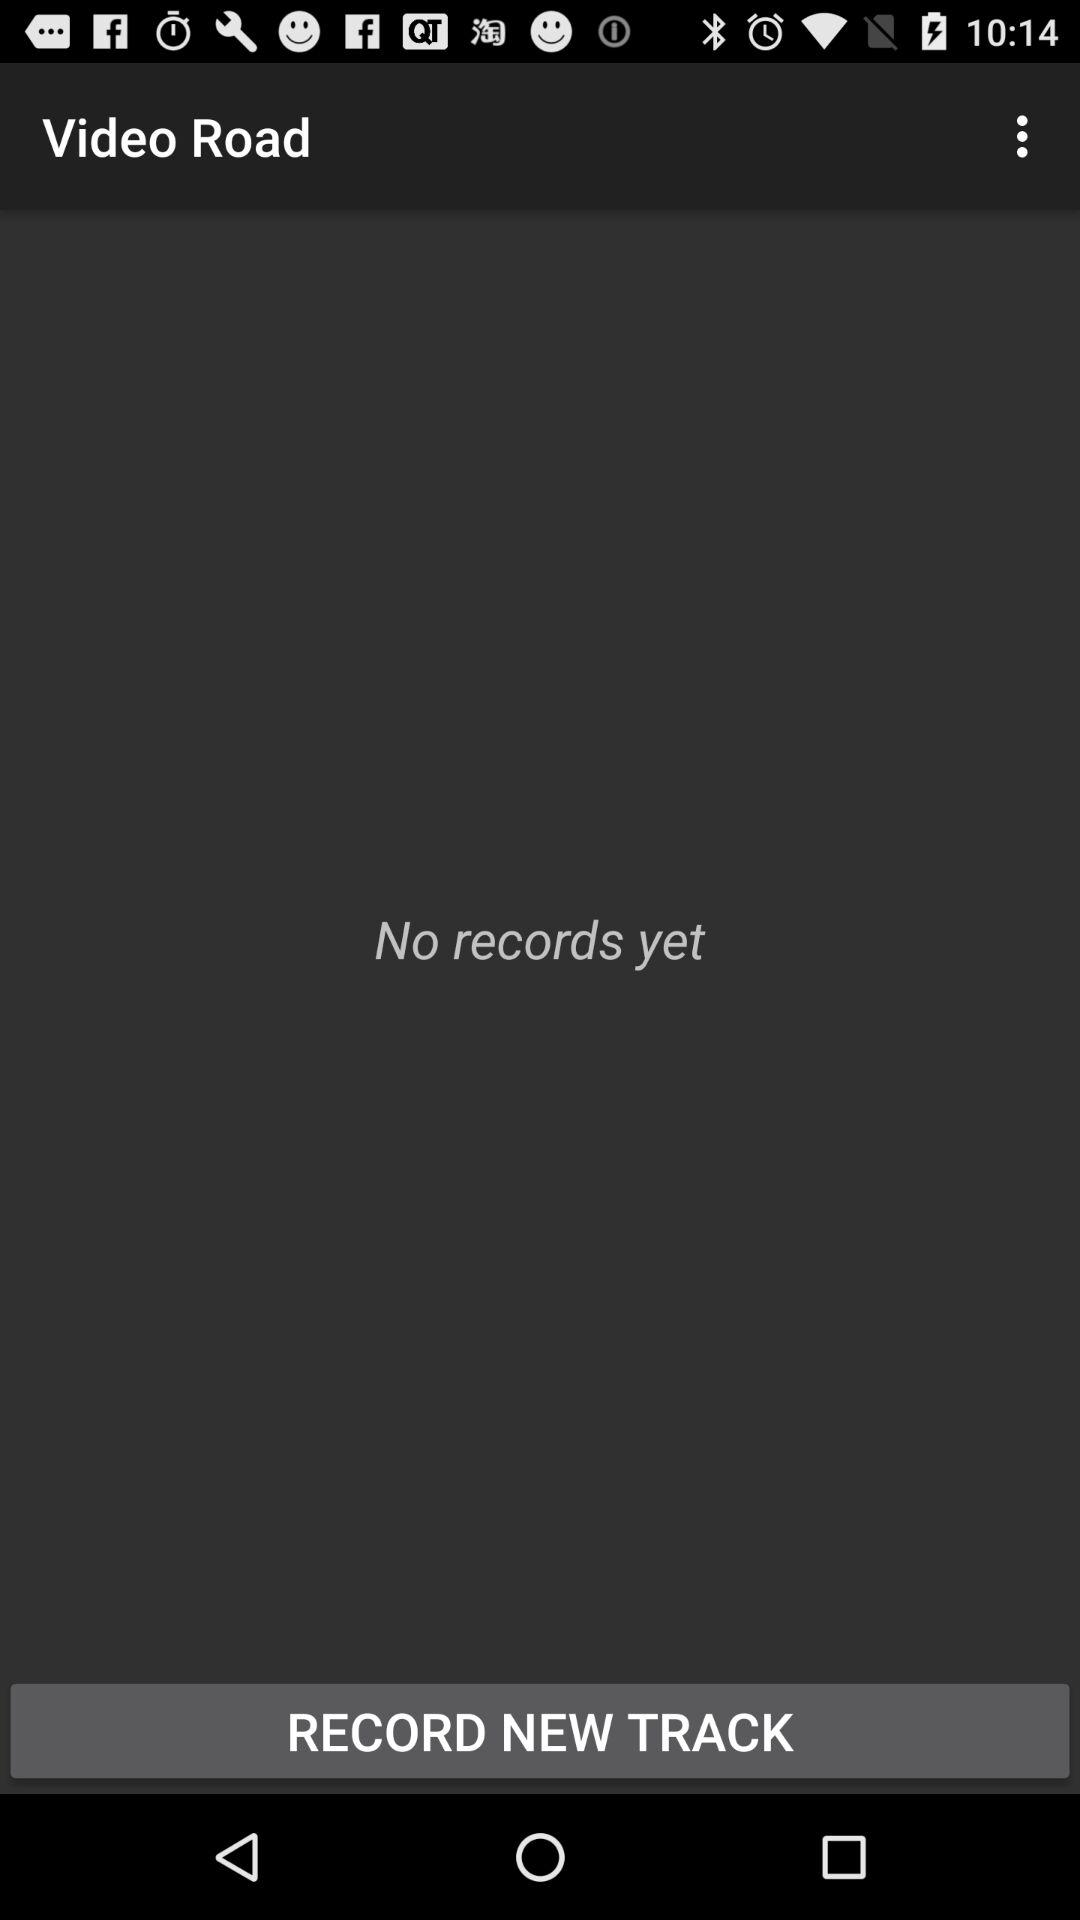What number of records do we have? You have no records yet. 